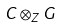<formula> <loc_0><loc_0><loc_500><loc_500>C \otimes _ { Z } G</formula> 